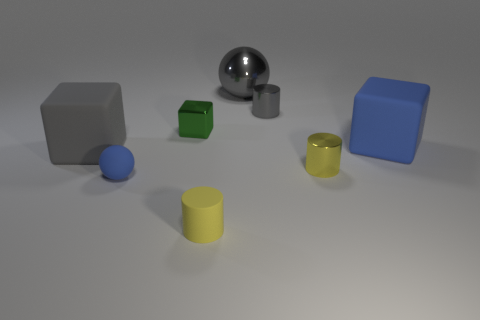What is the material of the block that is to the right of the yellow shiny thing?
Ensure brevity in your answer.  Rubber. Are there more big blue rubber cubes than small purple cylinders?
Provide a succinct answer. Yes. How many gray things are right of the small green metallic block and in front of the big gray shiny sphere?
Provide a short and direct response. 1. There is a small shiny cylinder that is right of the tiny gray shiny cylinder; how many small rubber spheres are to the right of it?
Your answer should be very brief. 0. What number of things are large matte things that are on the right side of the small rubber ball or big matte objects that are on the left side of the large gray metallic thing?
Keep it short and to the point. 2. What is the material of the blue thing that is the same shape as the large gray rubber object?
Keep it short and to the point. Rubber. What number of things are either large gray objects that are to the right of the large gray rubber cube or rubber cylinders?
Keep it short and to the point. 2. What shape is the tiny green thing that is made of the same material as the small gray cylinder?
Your response must be concise. Cube. What number of other small rubber objects are the same shape as the yellow rubber object?
Your answer should be very brief. 0. What is the material of the tiny gray cylinder?
Your answer should be compact. Metal. 